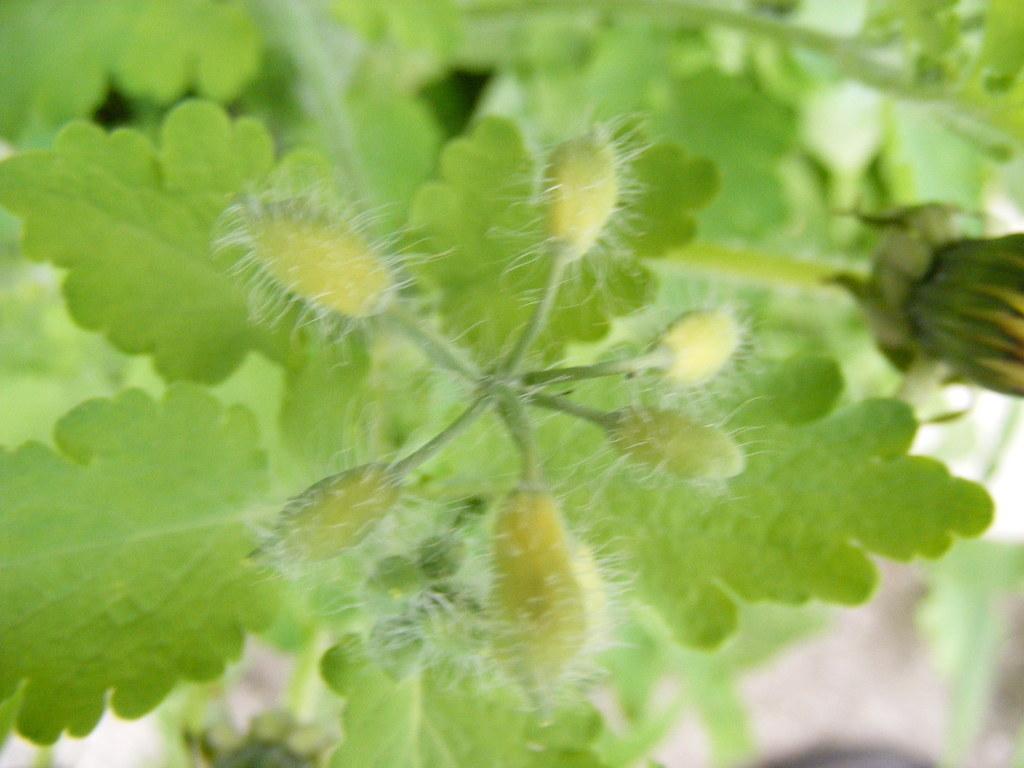Describe this image in one or two sentences. In this image, we can see leaves and buds. 